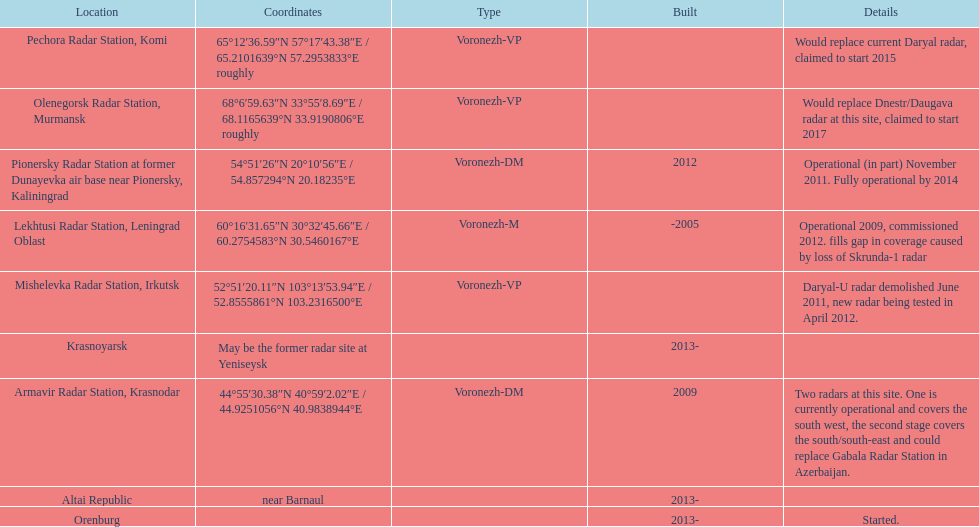What is the total number of locations? 9. 